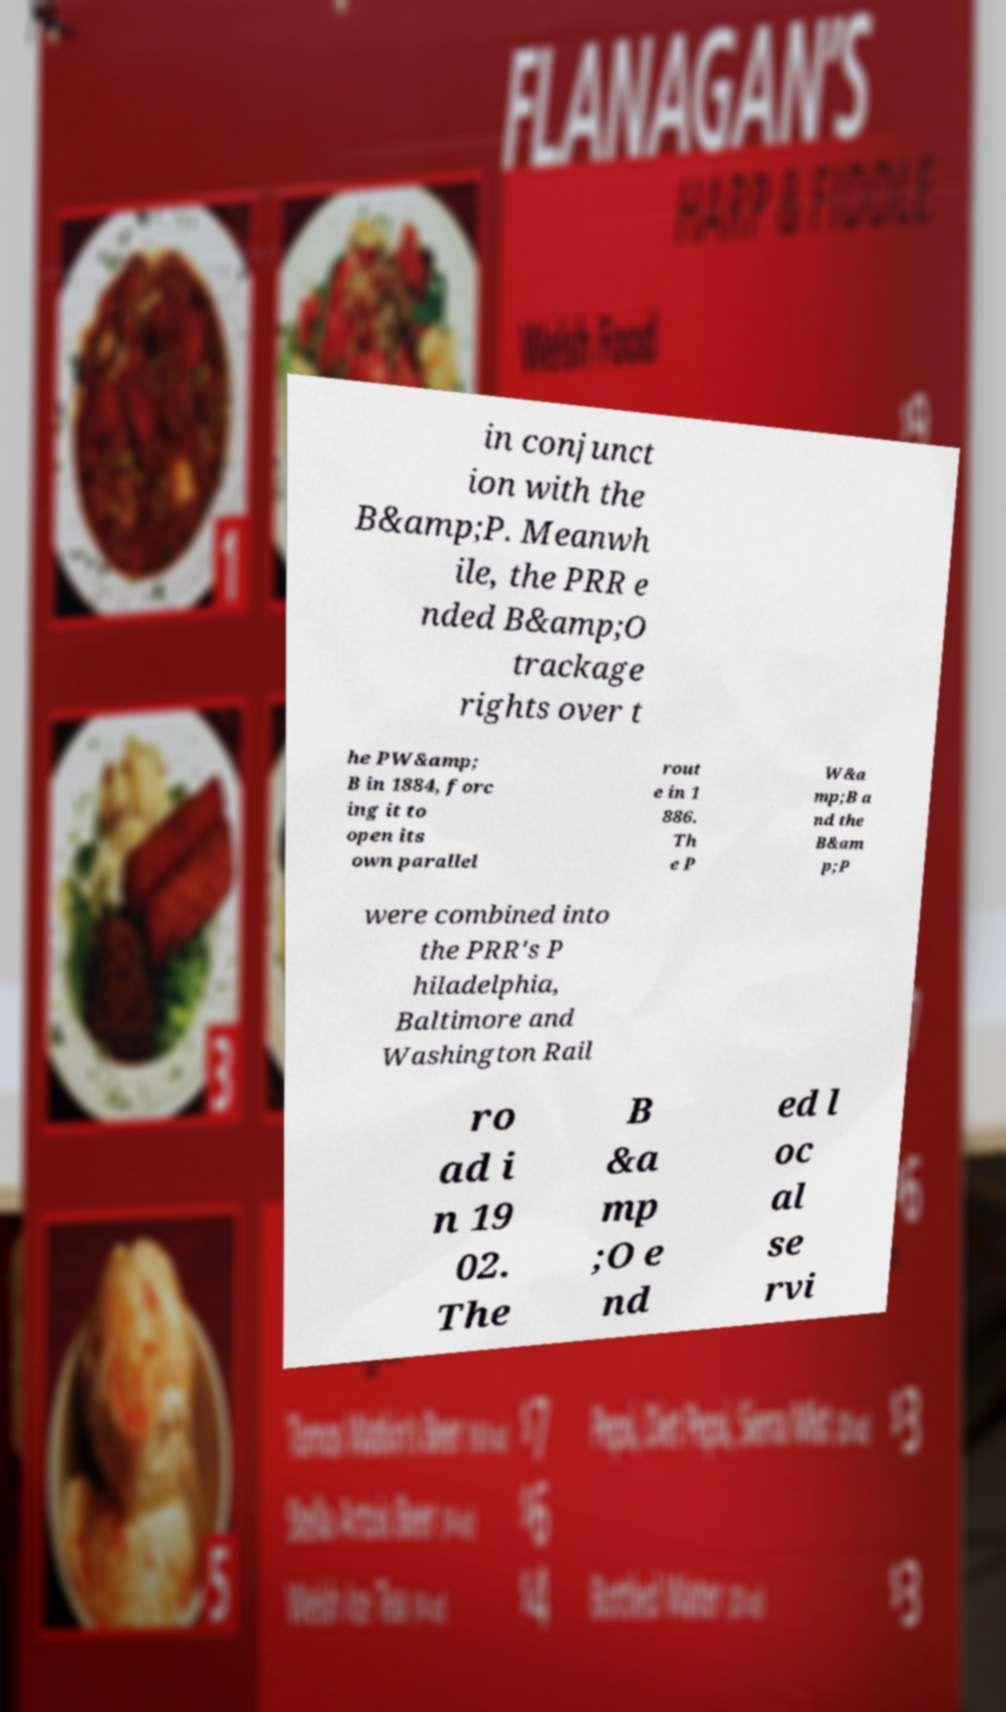Could you extract and type out the text from this image? in conjunct ion with the B&amp;P. Meanwh ile, the PRR e nded B&amp;O trackage rights over t he PW&amp; B in 1884, forc ing it to open its own parallel rout e in 1 886. Th e P W&a mp;B a nd the B&am p;P were combined into the PRR's P hiladelphia, Baltimore and Washington Rail ro ad i n 19 02. The B &a mp ;O e nd ed l oc al se rvi 